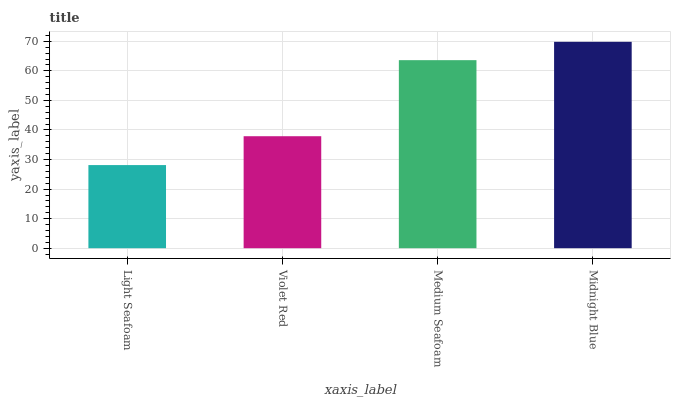Is Light Seafoam the minimum?
Answer yes or no. Yes. Is Midnight Blue the maximum?
Answer yes or no. Yes. Is Violet Red the minimum?
Answer yes or no. No. Is Violet Red the maximum?
Answer yes or no. No. Is Violet Red greater than Light Seafoam?
Answer yes or no. Yes. Is Light Seafoam less than Violet Red?
Answer yes or no. Yes. Is Light Seafoam greater than Violet Red?
Answer yes or no. No. Is Violet Red less than Light Seafoam?
Answer yes or no. No. Is Medium Seafoam the high median?
Answer yes or no. Yes. Is Violet Red the low median?
Answer yes or no. Yes. Is Midnight Blue the high median?
Answer yes or no. No. Is Light Seafoam the low median?
Answer yes or no. No. 